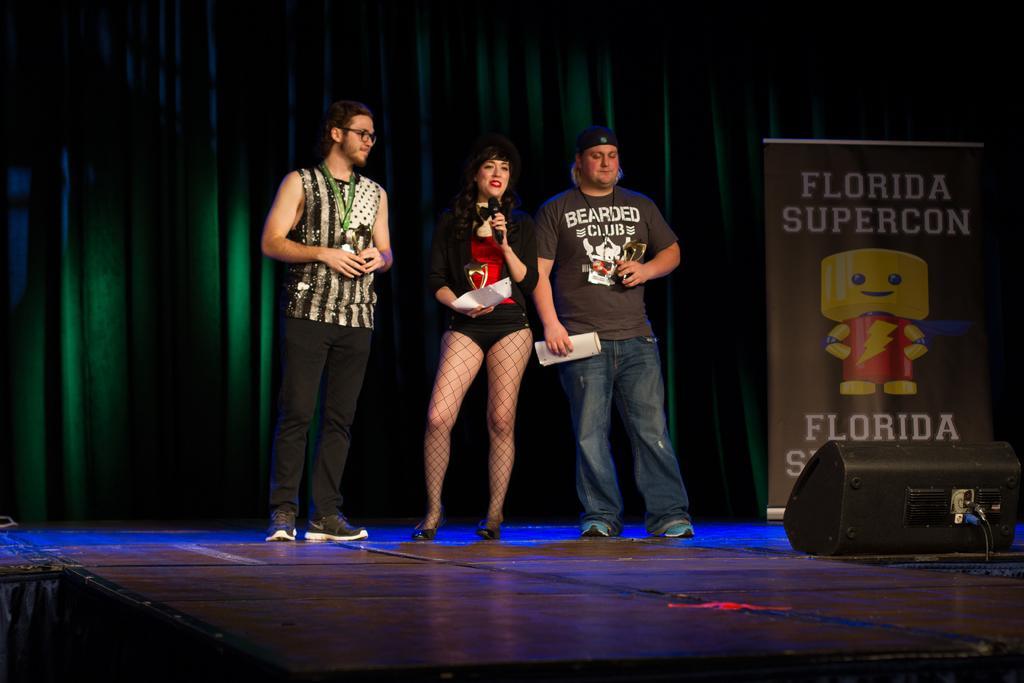In one or two sentences, can you explain what this image depicts? In this picture there is a woman who is holding a paper and mic. Beside her there is a man who is wearing a cap, t-shirt, jeans and shoes. He is holding the papers. On the left there is a man who is standing on the stage. In the bottom right I can see the speaker. In the back I can see the banner near to the green cloth. 